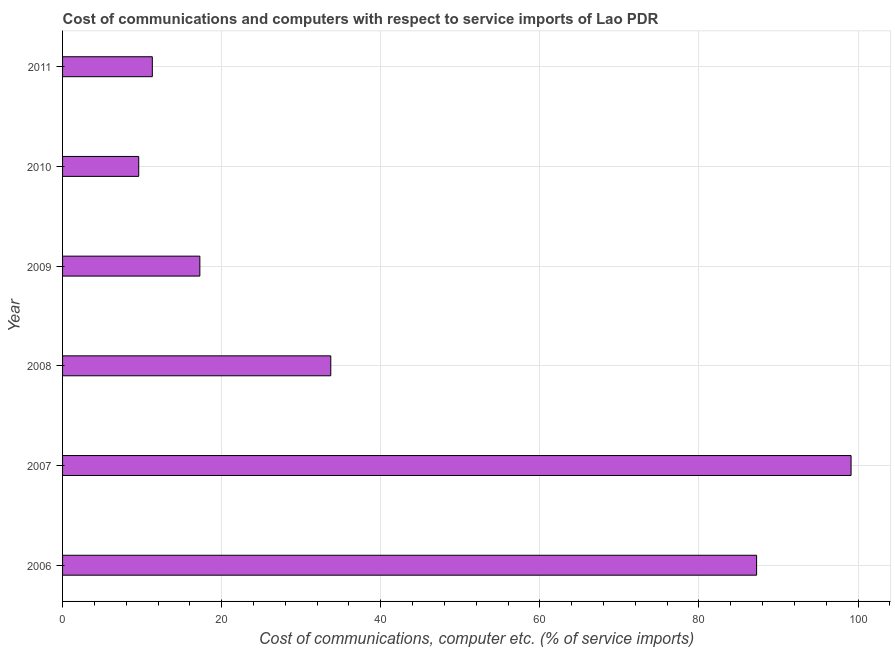Does the graph contain grids?
Offer a terse response. Yes. What is the title of the graph?
Provide a short and direct response. Cost of communications and computers with respect to service imports of Lao PDR. What is the label or title of the X-axis?
Provide a short and direct response. Cost of communications, computer etc. (% of service imports). What is the cost of communications and computer in 2008?
Your response must be concise. 33.72. Across all years, what is the maximum cost of communications and computer?
Your answer should be compact. 99.13. Across all years, what is the minimum cost of communications and computer?
Provide a succinct answer. 9.57. In which year was the cost of communications and computer maximum?
Make the answer very short. 2007. In which year was the cost of communications and computer minimum?
Your answer should be compact. 2010. What is the sum of the cost of communications and computer?
Ensure brevity in your answer.  258.22. What is the difference between the cost of communications and computer in 2009 and 2010?
Give a very brief answer. 7.69. What is the average cost of communications and computer per year?
Your answer should be compact. 43.04. What is the median cost of communications and computer?
Your answer should be compact. 25.49. In how many years, is the cost of communications and computer greater than 84 %?
Give a very brief answer. 2. What is the ratio of the cost of communications and computer in 2009 to that in 2010?
Keep it short and to the point. 1.8. Is the difference between the cost of communications and computer in 2007 and 2010 greater than the difference between any two years?
Make the answer very short. Yes. What is the difference between the highest and the second highest cost of communications and computer?
Keep it short and to the point. 11.88. What is the difference between the highest and the lowest cost of communications and computer?
Offer a very short reply. 89.55. Are the values on the major ticks of X-axis written in scientific E-notation?
Offer a very short reply. No. What is the Cost of communications, computer etc. (% of service imports) of 2006?
Offer a very short reply. 87.25. What is the Cost of communications, computer etc. (% of service imports) in 2007?
Keep it short and to the point. 99.13. What is the Cost of communications, computer etc. (% of service imports) of 2008?
Your response must be concise. 33.72. What is the Cost of communications, computer etc. (% of service imports) in 2009?
Give a very brief answer. 17.26. What is the Cost of communications, computer etc. (% of service imports) in 2010?
Your answer should be compact. 9.57. What is the Cost of communications, computer etc. (% of service imports) of 2011?
Your response must be concise. 11.29. What is the difference between the Cost of communications, computer etc. (% of service imports) in 2006 and 2007?
Offer a terse response. -11.88. What is the difference between the Cost of communications, computer etc. (% of service imports) in 2006 and 2008?
Provide a succinct answer. 53.53. What is the difference between the Cost of communications, computer etc. (% of service imports) in 2006 and 2009?
Offer a terse response. 69.99. What is the difference between the Cost of communications, computer etc. (% of service imports) in 2006 and 2010?
Ensure brevity in your answer.  77.68. What is the difference between the Cost of communications, computer etc. (% of service imports) in 2006 and 2011?
Offer a very short reply. 75.97. What is the difference between the Cost of communications, computer etc. (% of service imports) in 2007 and 2008?
Make the answer very short. 65.41. What is the difference between the Cost of communications, computer etc. (% of service imports) in 2007 and 2009?
Your response must be concise. 81.87. What is the difference between the Cost of communications, computer etc. (% of service imports) in 2007 and 2010?
Your answer should be compact. 89.55. What is the difference between the Cost of communications, computer etc. (% of service imports) in 2007 and 2011?
Your answer should be very brief. 87.84. What is the difference between the Cost of communications, computer etc. (% of service imports) in 2008 and 2009?
Offer a very short reply. 16.46. What is the difference between the Cost of communications, computer etc. (% of service imports) in 2008 and 2010?
Provide a short and direct response. 24.15. What is the difference between the Cost of communications, computer etc. (% of service imports) in 2008 and 2011?
Ensure brevity in your answer.  22.43. What is the difference between the Cost of communications, computer etc. (% of service imports) in 2009 and 2010?
Provide a succinct answer. 7.69. What is the difference between the Cost of communications, computer etc. (% of service imports) in 2009 and 2011?
Give a very brief answer. 5.98. What is the difference between the Cost of communications, computer etc. (% of service imports) in 2010 and 2011?
Keep it short and to the point. -1.71. What is the ratio of the Cost of communications, computer etc. (% of service imports) in 2006 to that in 2007?
Provide a short and direct response. 0.88. What is the ratio of the Cost of communications, computer etc. (% of service imports) in 2006 to that in 2008?
Provide a succinct answer. 2.59. What is the ratio of the Cost of communications, computer etc. (% of service imports) in 2006 to that in 2009?
Give a very brief answer. 5.05. What is the ratio of the Cost of communications, computer etc. (% of service imports) in 2006 to that in 2010?
Make the answer very short. 9.11. What is the ratio of the Cost of communications, computer etc. (% of service imports) in 2006 to that in 2011?
Give a very brief answer. 7.73. What is the ratio of the Cost of communications, computer etc. (% of service imports) in 2007 to that in 2008?
Keep it short and to the point. 2.94. What is the ratio of the Cost of communications, computer etc. (% of service imports) in 2007 to that in 2009?
Give a very brief answer. 5.74. What is the ratio of the Cost of communications, computer etc. (% of service imports) in 2007 to that in 2010?
Provide a succinct answer. 10.35. What is the ratio of the Cost of communications, computer etc. (% of service imports) in 2007 to that in 2011?
Offer a terse response. 8.78. What is the ratio of the Cost of communications, computer etc. (% of service imports) in 2008 to that in 2009?
Offer a terse response. 1.95. What is the ratio of the Cost of communications, computer etc. (% of service imports) in 2008 to that in 2010?
Provide a succinct answer. 3.52. What is the ratio of the Cost of communications, computer etc. (% of service imports) in 2008 to that in 2011?
Keep it short and to the point. 2.99. What is the ratio of the Cost of communications, computer etc. (% of service imports) in 2009 to that in 2010?
Give a very brief answer. 1.8. What is the ratio of the Cost of communications, computer etc. (% of service imports) in 2009 to that in 2011?
Offer a very short reply. 1.53. What is the ratio of the Cost of communications, computer etc. (% of service imports) in 2010 to that in 2011?
Provide a succinct answer. 0.85. 